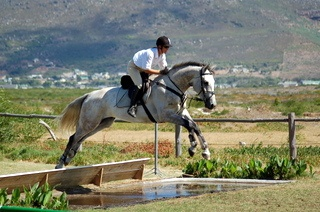Describe the objects in this image and their specific colors. I can see horse in gray, black, and lightgray tones and people in gray, black, darkgray, and white tones in this image. 